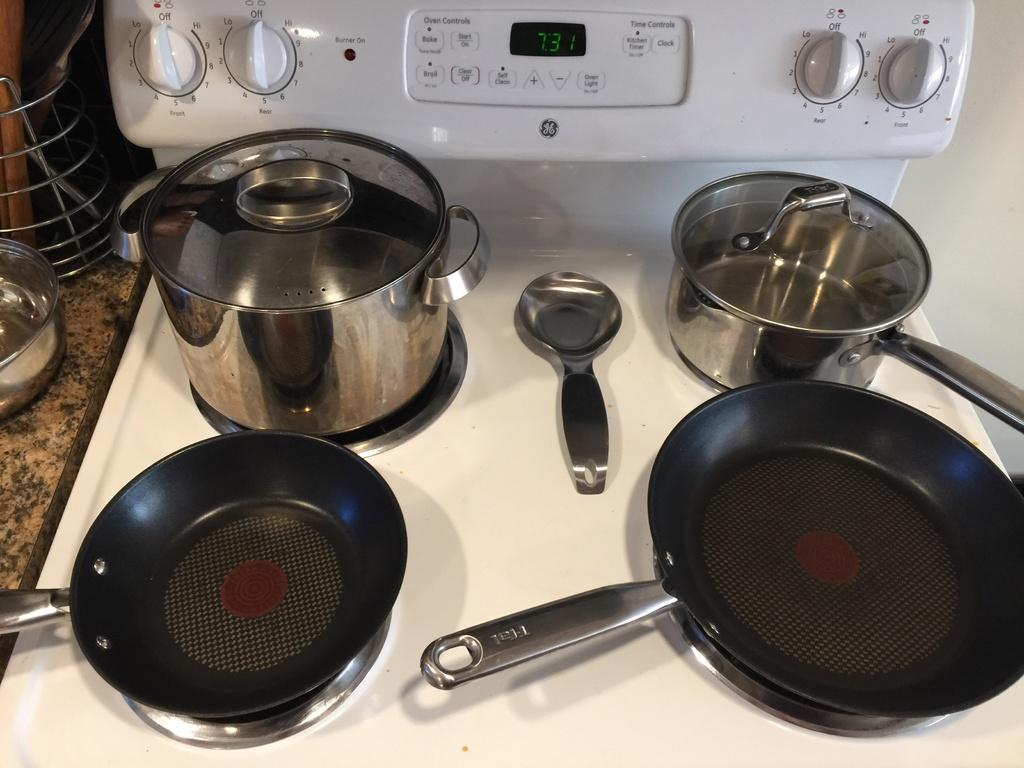<image>
Render a clear and concise summary of the photo. An electric stove with clean empty pots and pans on it and the display says 7:31. 